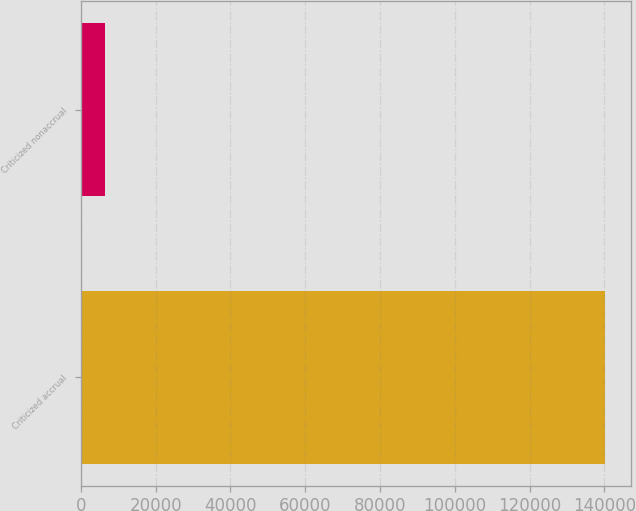Convert chart. <chart><loc_0><loc_0><loc_500><loc_500><bar_chart><fcel>Criticized accrual<fcel>Criticized nonaccrual<nl><fcel>140119<fcel>6451<nl></chart> 